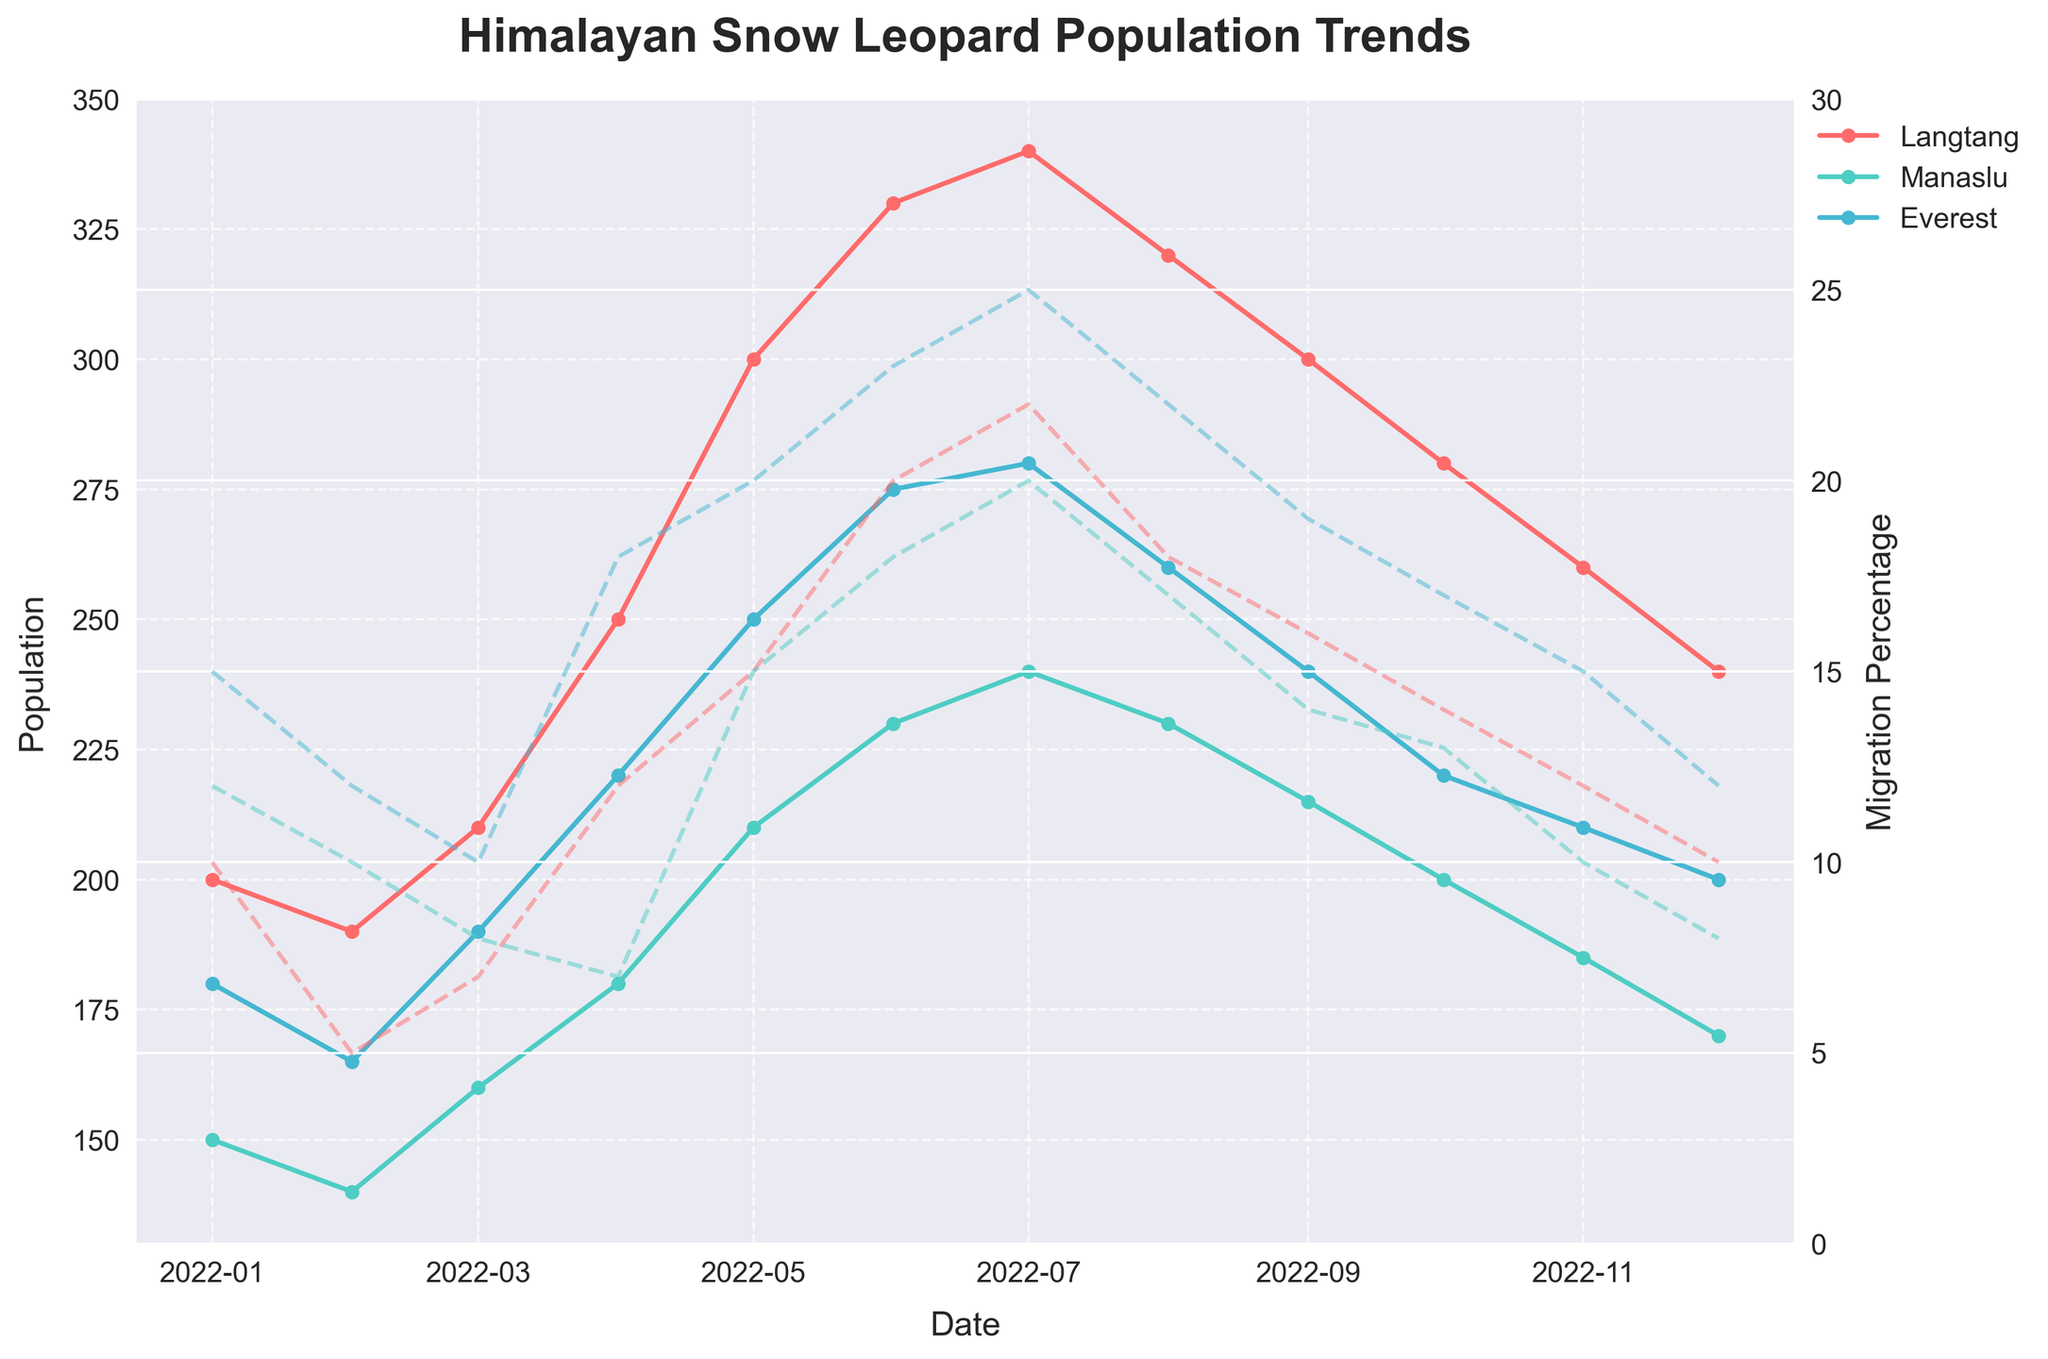What is the title of the figure? The title can be found at the top of the figure. It reads 'Himalayan Snow Leopard Population Trends'.
Answer: Himalayan Snow Leopard Population Trends Which region shows the highest population in July 2022? The population peaks in different months can be seen by looking at each region's line. For July 2022, the region with the highest population is Everest, which has a population of 280.
Answer: Everest What is the migration percentage in Langtang in June 2022? To find this, locate June 2022 on the x-axis and follow the Langtang line to the right y-axis (Migration Percentage). The value is 20.
Answer: 20 Which month and region exhibit the lowest migration percentage? By examining the lines corresponding to Migration Percentage for all regions across all months, Manaslu in April 2022 shows the lowest migration percentage of 7.
Answer: Manaslu, April 2022 Comparing Langtang and Everest, which region has a higher population in December 2022? Locate December 2022 on the x-axis, and compare the population values of Langtang and Everest. Langtang's population is 240, while Everest is 200. Therefore, Langtang has a higher population in December 2022.
Answer: Langtang What is the overall trend observed in the population of snow leopards in the Manaslu region from January to December 2022? The trend can be identified by observing the line corresponding to Manaslu from January to December. It generally increases until July and then declines.
Answer: Increases, then decreases During which months is the migration percentage higher in Everest region compared to Langtang? Compare the Migration Percentage lines for Everest and Langtang. The months where Everest's percentage is higher than Langtang are April, May, June, July, August, September, October, and November.
Answer: April to November How does the migration percentage trend in Everest compare to Langtang in June 2022? By checking the June 2022 data point on the Migration Percentage lines for both regions, Everest shows a 23% migration, while Langtang shows a 20% migration. Everest's migration percentage is higher in June 2022.
Answer: Everest higher What is the difference in the population of snow leopards between Manaslu and Langtang in May 2022? Find the population values for May 2022 for both regions. Manaslu has 210 and Langtang has 300. The difference is 90 leopards.
Answer: 90 Which region exhibits the most consistent migration percentage trend throughout the year? Consistency can be determined by observing the fluctuation in the Migration Percentage lines. Manaslu shows the most consistent trend with the least variation.
Answer: Manaslu 